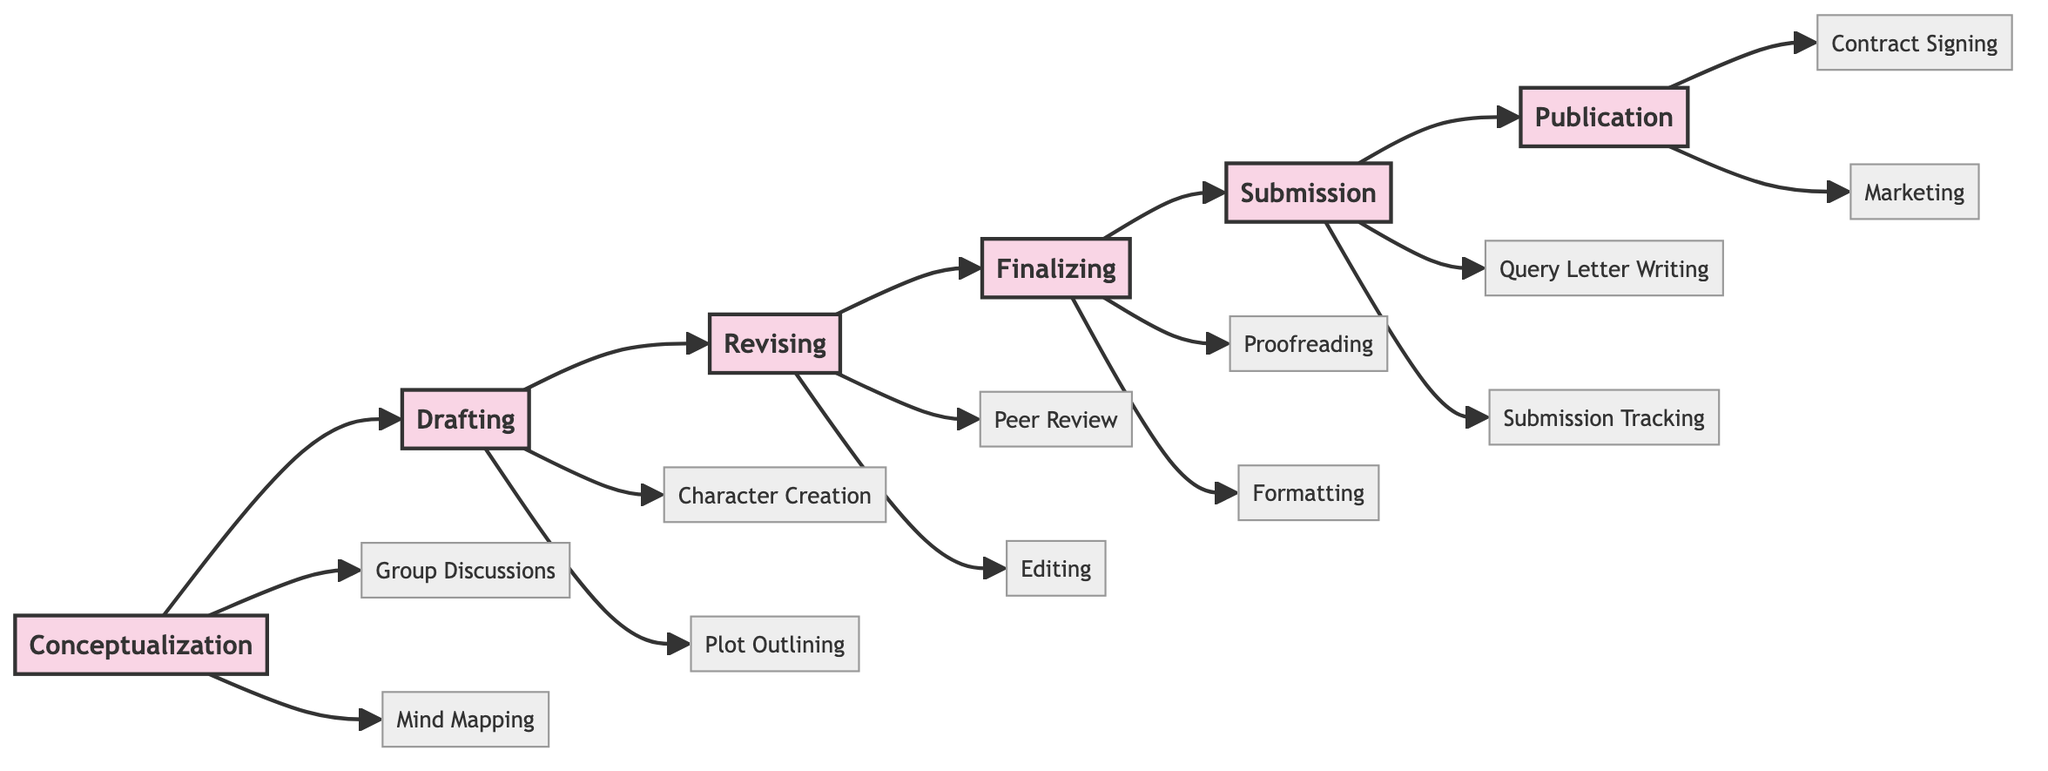What stage comes after Drafting? In the flowchart, Drafting is followed by the next stage, which is indicated by the arrow leading to it. The next stage is Revising.
Answer: Revising How many main stages are in the flowchart? By counting the number of main stages connected in a linear flow, we find six stages: Conceptualization, Drafting, Revising, Finalizing, Submission, and Publication.
Answer: Six What activities are associated with Finalizing? Following the Finalizing stage, there are two activities connected to it, which are Proofreading and Formatting. These activities provide additional details on what takes place during this stage.
Answer: Proofreading, Formatting Which stage includes Peer Review as an activity? The diagram indicates that Peer Review is an activity that takes place specifically in the Revising stage. This can be identified by tracing the activities linked to that stage.
Answer: Revising What comes before Submission? To find what comes before Submission, we look at the flow of the diagram and note that the previous stage is Finalizing, leading directly into Submission.
Answer: Finalizing How many activities are listed under Conceptualization? By examining the Conceptualization stage in the diagram, we find two activities linked to it: Group Discussions and Mind Mapping. Thus, the total number of activities in this stage is counted.
Answer: Two What is the last activity in the publication process? In the flowchart, the last activity related to the Publication stage is Marketing. This is determined by checking the activities linked to the Publication stage.
Answer: Marketing What is the relationship between Drafting and Revising? The relationship between Drafting and Revising in the diagram is that Drafting leads directly to Revising, indicating that once a draft is created, it is then revised.
Answer: Drafting leads to Revising What is the first activity listed under the Drafting stage? The first activity under Drafting, as seen in the diagram, is Character Creation. This can be directly identified from the activities branching out from the Drafting stage.
Answer: Character Creation 